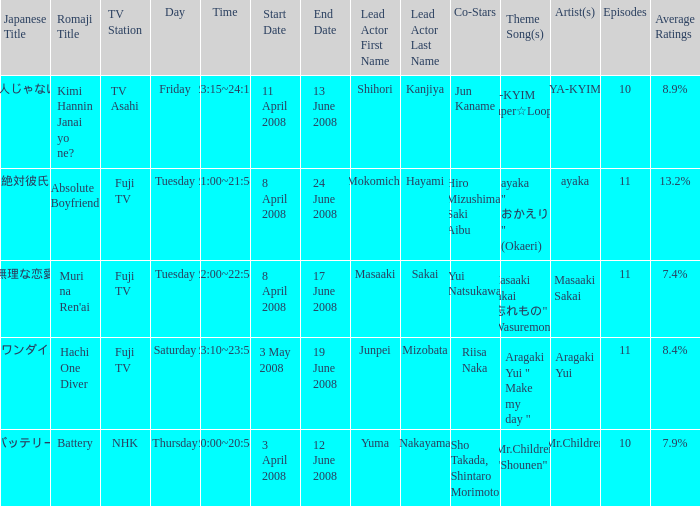What are the japanese title(s) for tv asahi? キミ犯人じゃないよね?. 